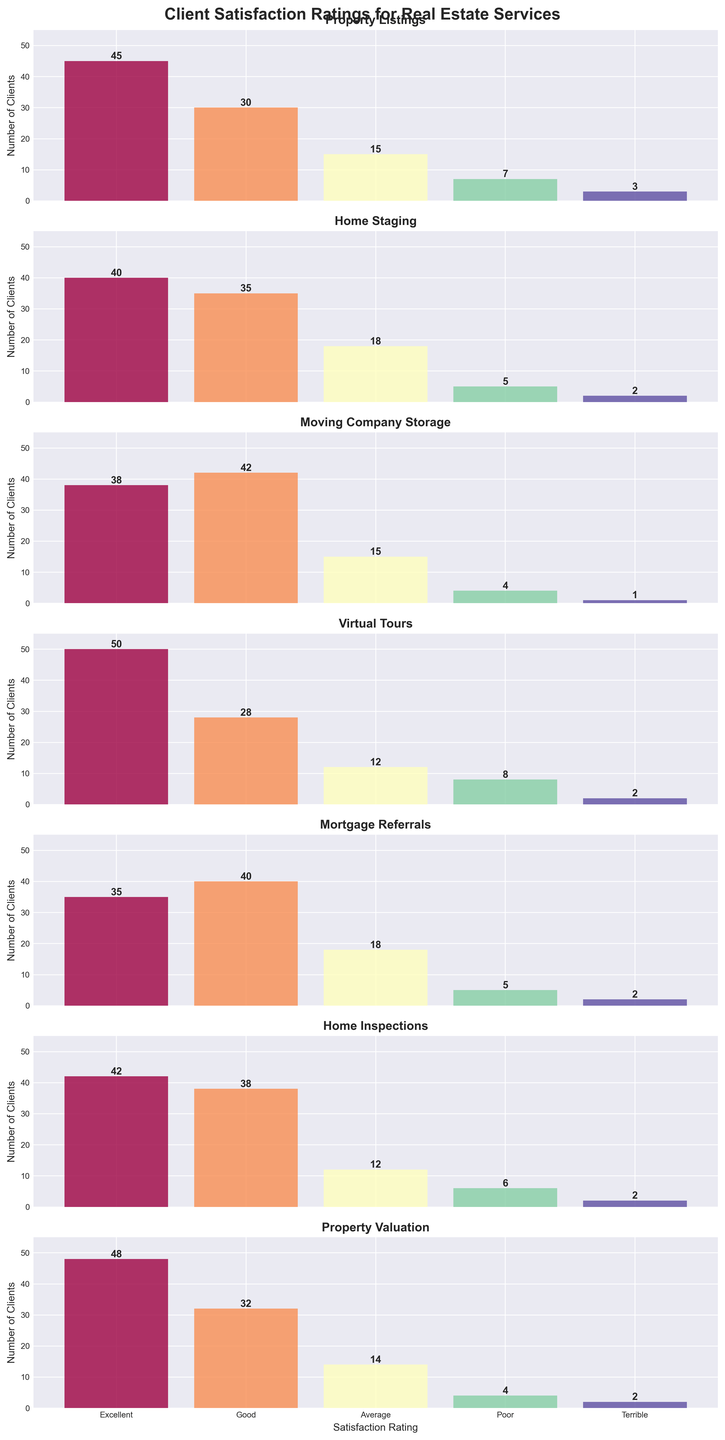What's the title of the figure? The title of the figure is positioned at the top and is often used to give a brief description of what the figure represents. In this case, look at the top of the subplots to find the title.
Answer: Client Satisfaction Ratings for Real Estate Services Which service received the highest number of 'Excellent' ratings? Look at the 'Excellent' bars across all the subplots and identify the one that reaches the highest value.
Answer: Virtual Tours How do the 'Good' ratings for Moving Company Storage compare to Home Inspections? Compare the heights of the 'Good' bars between Moving Company Storage and Home Inspections. The 'Good' bar for Moving Company Storage is taller than the one for Home Inspections.
Answer: Higher What's the total number of 'Poor' ratings across all services? Sum up the values of the 'Poor' bars for all subplots. These values are 7, 5, 4, 8, 5, 6, and 4. The total is 7 + 5 + 4 + 8 + 5 + 6 + 4.
Answer: 39 Which two services share the same number of 'Terrible' ratings? Examine the 'Terrible' bars and identify two services with bars of equal height.
Answer: Home Staging and Mortgage Referrals What is the average number of 'Excellent' ratings across all services? Sum the 'Excellent' ratings: 45, 40, 38, 50, 35, 42, and 48. The total is 298. Divide this by the number of services, which is 7.
Answer: 42.57 Are there more 'Average' ratings for Property Listings or Property Valuation? Compare the heights of the 'Average' bars for Property Listings and Property Valuation. The 'Average' bar for Property Listings is higher than the one for Property Valuation.
Answer: Property Listings Which service has the lowest number of 'Terrible' ratings? Identify the shortest 'Terrible' bar among all the services. The shortest bar corresponds to Moving Company Storage.
Answer: Moving Company Storage What's the difference in the 'Good' ratings between Mortgage Referrals and Home Staging? Subtract the 'Good' ratings of Home Staging from Mortgage Referrals. Home Staging has 35 'Good' ratings, while Mortgage Referrals have 40. The difference is 40 - 35.
Answer: 5 What is the range of 'Average' ratings across all services? Identify the highest and lowest 'Average' ratings across the subplots. The highest is 18 (Home Staging and Mortgage Referrals) and the lowest is 12 (Virtual Tours and Home Inspections). The range is 18 - 12.
Answer: 6 